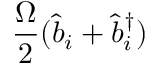<formula> <loc_0><loc_0><loc_500><loc_500>\frac { \Omega } { 2 } ( \hat { b } _ { i } + \hat { b } _ { i } ^ { \dagger } )</formula> 